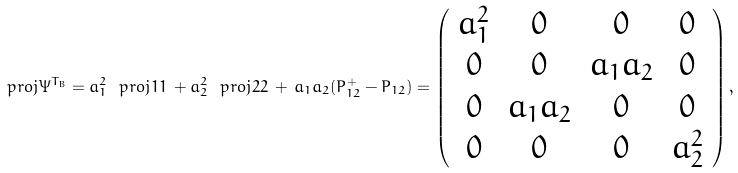Convert formula to latex. <formula><loc_0><loc_0><loc_500><loc_500>\ p r o j { \Psi } ^ { T _ { B } } = a _ { 1 } ^ { 2 } \ p r o j { 1 1 } \, + a _ { 2 } ^ { 2 } \ p r o j { 2 2 } \, + \, a _ { 1 } a _ { 2 } ( P _ { 1 2 } ^ { + } - P _ { 1 2 } ) = \left ( \begin{array} { c c c c } a _ { 1 } ^ { 2 } & 0 & 0 & 0 \\ 0 & 0 & a _ { 1 } a _ { 2 } & 0 \\ 0 & a _ { 1 } a _ { 2 } & 0 & 0 \\ 0 & 0 & 0 & a _ { 2 } ^ { 2 } \end{array} \right ) ,</formula> 